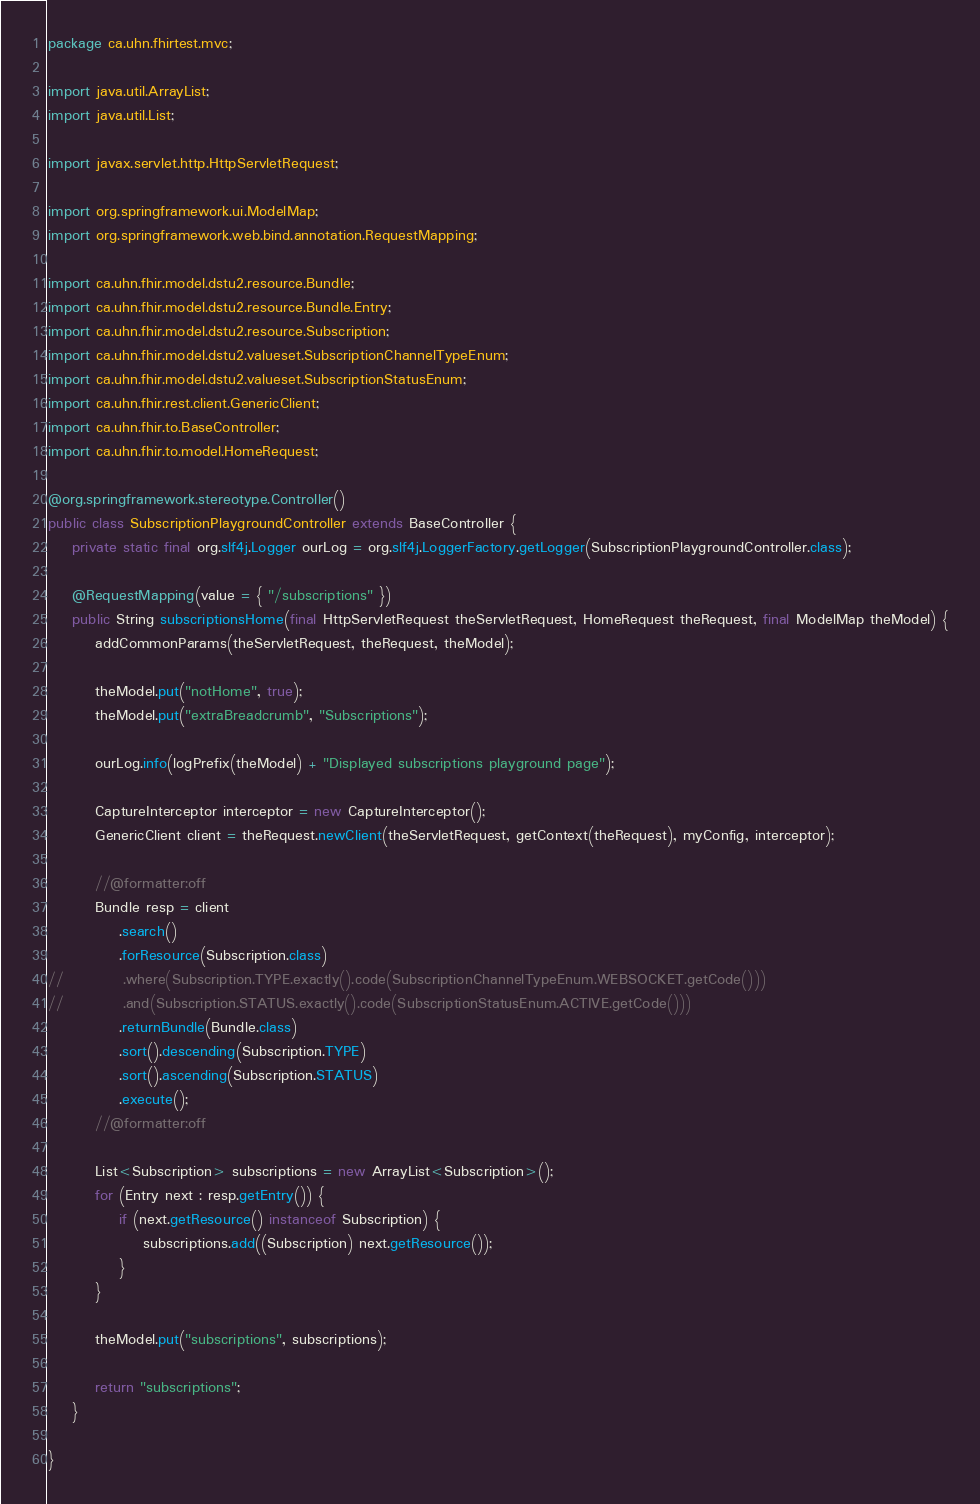Convert code to text. <code><loc_0><loc_0><loc_500><loc_500><_Java_>package ca.uhn.fhirtest.mvc;

import java.util.ArrayList;
import java.util.List;

import javax.servlet.http.HttpServletRequest;

import org.springframework.ui.ModelMap;
import org.springframework.web.bind.annotation.RequestMapping;

import ca.uhn.fhir.model.dstu2.resource.Bundle;
import ca.uhn.fhir.model.dstu2.resource.Bundle.Entry;
import ca.uhn.fhir.model.dstu2.resource.Subscription;
import ca.uhn.fhir.model.dstu2.valueset.SubscriptionChannelTypeEnum;
import ca.uhn.fhir.model.dstu2.valueset.SubscriptionStatusEnum;
import ca.uhn.fhir.rest.client.GenericClient;
import ca.uhn.fhir.to.BaseController;
import ca.uhn.fhir.to.model.HomeRequest;

@org.springframework.stereotype.Controller()
public class SubscriptionPlaygroundController extends BaseController {
	private static final org.slf4j.Logger ourLog = org.slf4j.LoggerFactory.getLogger(SubscriptionPlaygroundController.class);

	@RequestMapping(value = { "/subscriptions" })
	public String subscriptionsHome(final HttpServletRequest theServletRequest, HomeRequest theRequest, final ModelMap theModel) {
		addCommonParams(theServletRequest, theRequest, theModel);

		theModel.put("notHome", true);
		theModel.put("extraBreadcrumb", "Subscriptions");

		ourLog.info(logPrefix(theModel) + "Displayed subscriptions playground page");

		CaptureInterceptor interceptor = new CaptureInterceptor();
		GenericClient client = theRequest.newClient(theServletRequest, getContext(theRequest), myConfig, interceptor);

		//@formatter:off
		Bundle resp = client
			.search()
			.forResource(Subscription.class)
//			.where(Subscription.TYPE.exactly().code(SubscriptionChannelTypeEnum.WEBSOCKET.getCode()))
//			.and(Subscription.STATUS.exactly().code(SubscriptionStatusEnum.ACTIVE.getCode()))
			.returnBundle(Bundle.class)
			.sort().descending(Subscription.TYPE)
			.sort().ascending(Subscription.STATUS)
			.execute();
		//@formatter:off
		
		List<Subscription> subscriptions = new ArrayList<Subscription>();
		for (Entry next : resp.getEntry()) {
			if (next.getResource() instanceof Subscription) {
				subscriptions.add((Subscription) next.getResource());
			}
		}
		
		theModel.put("subscriptions", subscriptions);
		
		return "subscriptions";
	}

}
</code> 